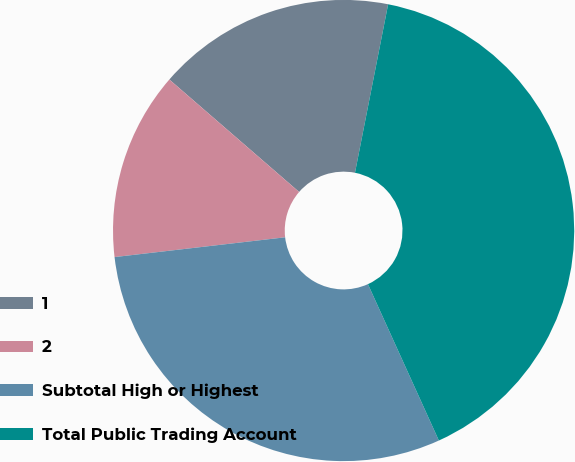Convert chart to OTSL. <chart><loc_0><loc_0><loc_500><loc_500><pie_chart><fcel>1<fcel>2<fcel>Subtotal High or Highest<fcel>Total Public Trading Account<nl><fcel>16.73%<fcel>13.2%<fcel>29.94%<fcel>40.13%<nl></chart> 